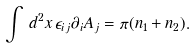<formula> <loc_0><loc_0><loc_500><loc_500>\int \, d ^ { 2 } x \, \epsilon _ { i j } \partial _ { i } A _ { j } = \pi ( n _ { 1 } + n _ { 2 } ) .</formula> 